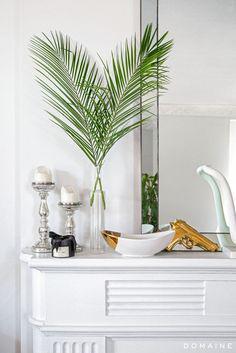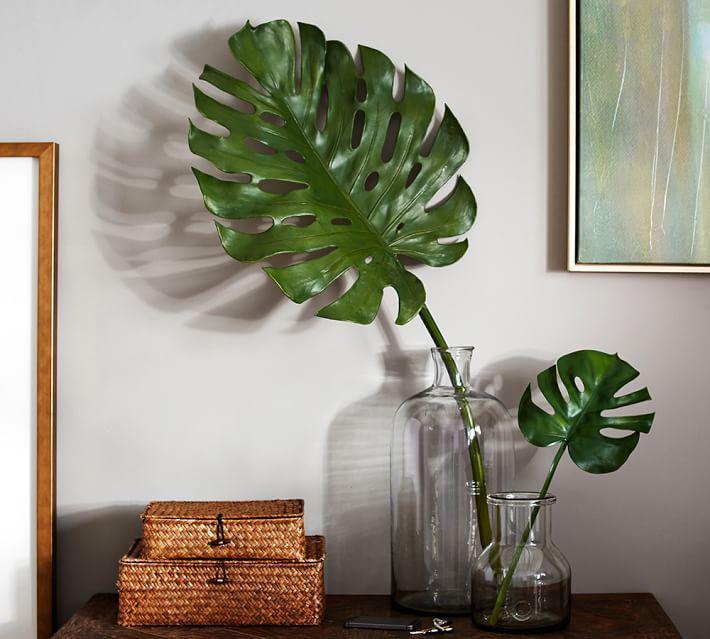The first image is the image on the left, the second image is the image on the right. Given the left and right images, does the statement "At least one of the images shows one or more candles next to a plant." hold true? Answer yes or no. Yes. The first image is the image on the left, the second image is the image on the right. For the images displayed, is the sentence "In one of the image there is vase with a plant in it in front of a window." factually correct? Answer yes or no. No. 